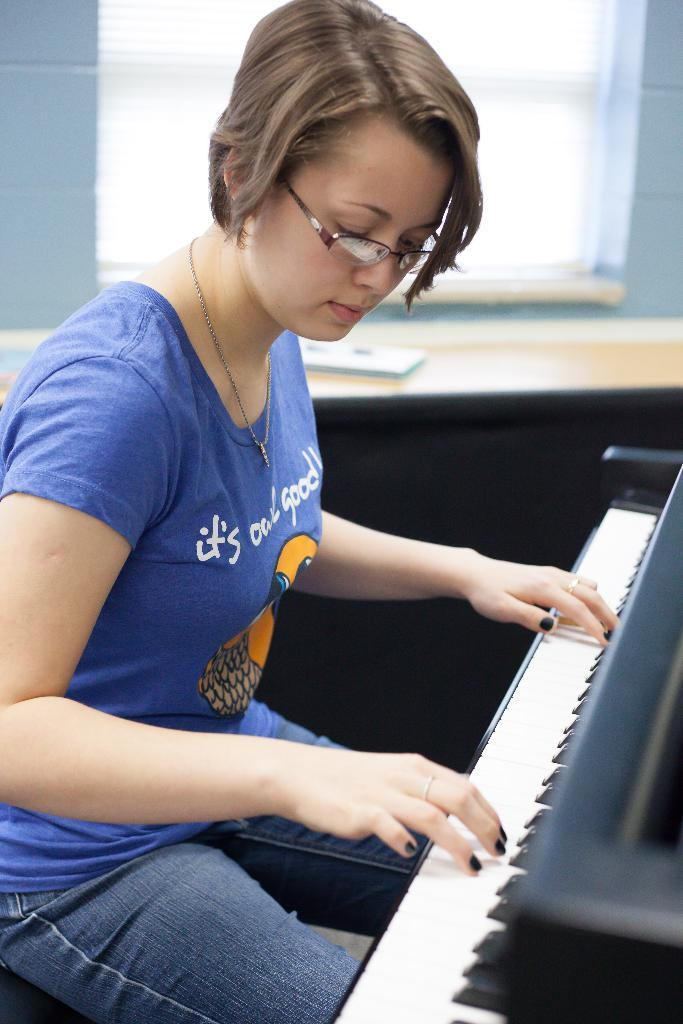What is the person in the image doing? The person is sitting on a chair and playing a musical keyboard. Can you describe the setting of the image? There is a window visible in the background. How does the person stop the motion of the musical keyboard during the voyage? There is no mention of a voyage or motion in the image, and the person is not shown stopping the musical keyboard. 